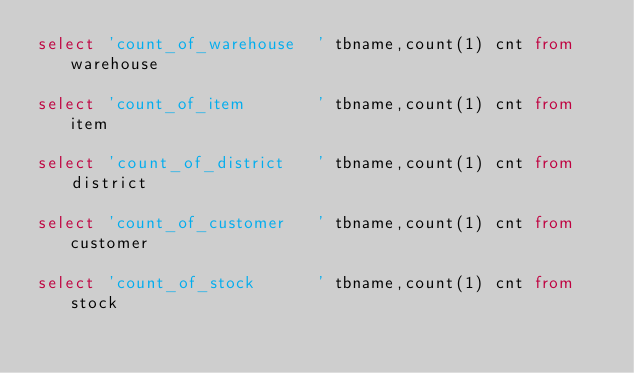Convert code to text. <code><loc_0><loc_0><loc_500><loc_500><_SQL_>select 'count_of_warehouse  ' tbname,count(1) cnt from warehouse  

select 'count_of_item       ' tbname,count(1) cnt from item       

select 'count_of_district   ' tbname,count(1) cnt from district   

select 'count_of_customer   ' tbname,count(1) cnt from customer   

select 'count_of_stock      ' tbname,count(1) cnt from stock      
</code> 